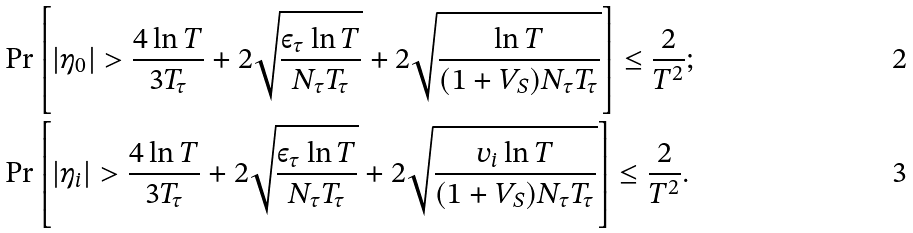<formula> <loc_0><loc_0><loc_500><loc_500>& \Pr \left [ | \eta _ { 0 } | > \frac { 4 \ln T } { 3 T _ { \tau } } + 2 \sqrt { \frac { \varepsilon _ { \tau } \ln T } { N _ { \tau } T _ { \tau } } } + 2 \sqrt { \frac { \ln T } { ( 1 + V _ { S } ) N _ { \tau } T _ { \tau } } } \right ] \leq \frac { 2 } { T ^ { 2 } } ; \\ & \Pr \left [ | \eta _ { i } | > \frac { 4 \ln T } { 3 T _ { \tau } } + 2 \sqrt { \frac { \varepsilon _ { \tau } \ln T } { N _ { \tau } T _ { \tau } } } + 2 \sqrt { \frac { v _ { i } \ln T } { ( 1 + V _ { S } ) N _ { \tau } T _ { \tau } } } \right ] \leq \frac { 2 } { T ^ { 2 } } .</formula> 